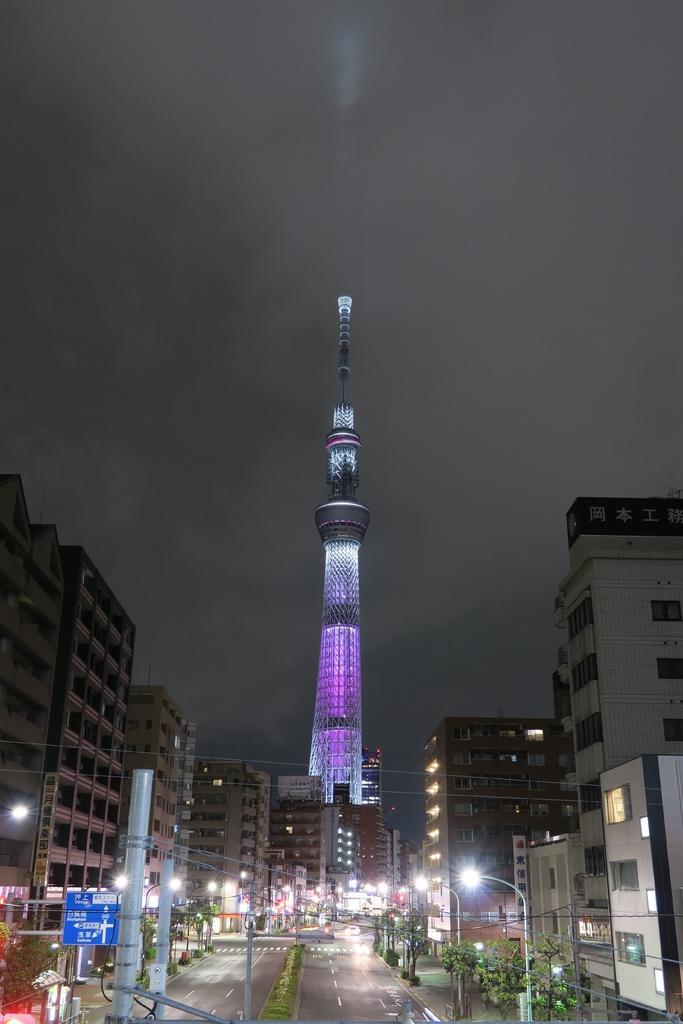Please provide a concise description of this image. In the foreground of this picture, there are building and the skyscraper in the background, there are also poles, trees, road and the sky. 